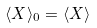Convert formula to latex. <formula><loc_0><loc_0><loc_500><loc_500>\langle X \rangle _ { 0 } = \langle X \rangle</formula> 